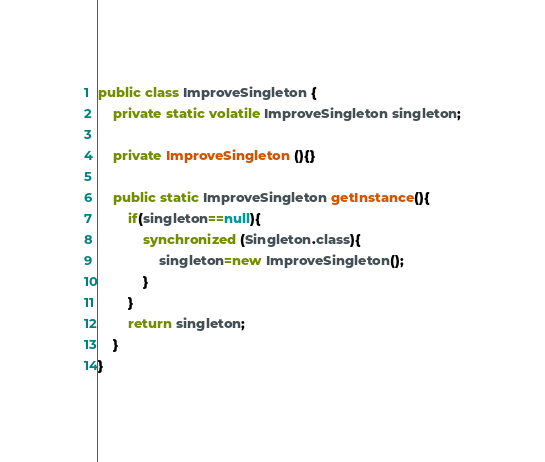<code> <loc_0><loc_0><loc_500><loc_500><_Java_>public class ImproveSingleton {
    private static volatile ImproveSingleton singleton;

    private ImproveSingleton (){}

    public static ImproveSingleton getInstance(){
        if(singleton==null){
            synchronized (Singleton.class){
                singleton=new ImproveSingleton();
            }
        }
        return singleton;
    }
}</code> 